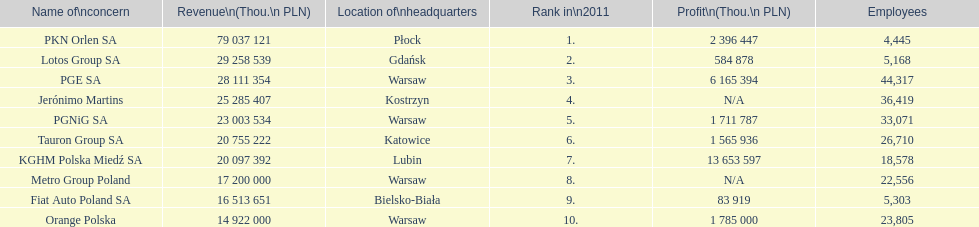Can you parse all the data within this table? {'header': ['Name of\\nconcern', 'Revenue\\n(Thou.\\n\xa0PLN)', 'Location of\\nheadquarters', 'Rank in\\n2011', 'Profit\\n(Thou.\\n\xa0PLN)', 'Employees'], 'rows': [['PKN Orlen SA', '79 037 121', 'Płock', '1.', '2 396 447', '4,445'], ['Lotos Group SA', '29 258 539', 'Gdańsk', '2.', '584 878', '5,168'], ['PGE SA', '28 111 354', 'Warsaw', '3.', '6 165 394', '44,317'], ['Jerónimo Martins', '25 285 407', 'Kostrzyn', '4.', 'N/A', '36,419'], ['PGNiG SA', '23 003 534', 'Warsaw', '5.', '1 711 787', '33,071'], ['Tauron Group SA', '20 755 222', 'Katowice', '6.', '1 565 936', '26,710'], ['KGHM Polska Miedź SA', '20 097 392', 'Lubin', '7.', '13 653 597', '18,578'], ['Metro Group Poland', '17 200 000', 'Warsaw', '8.', 'N/A', '22,556'], ['Fiat Auto Poland SA', '16 513 651', 'Bielsko-Biała', '9.', '83 919', '5,303'], ['Orange Polska', '14 922 000', 'Warsaw', '10.', '1 785 000', '23,805']]} What is the difference in employees for rank 1 and rank 3? 39,872 employees. 